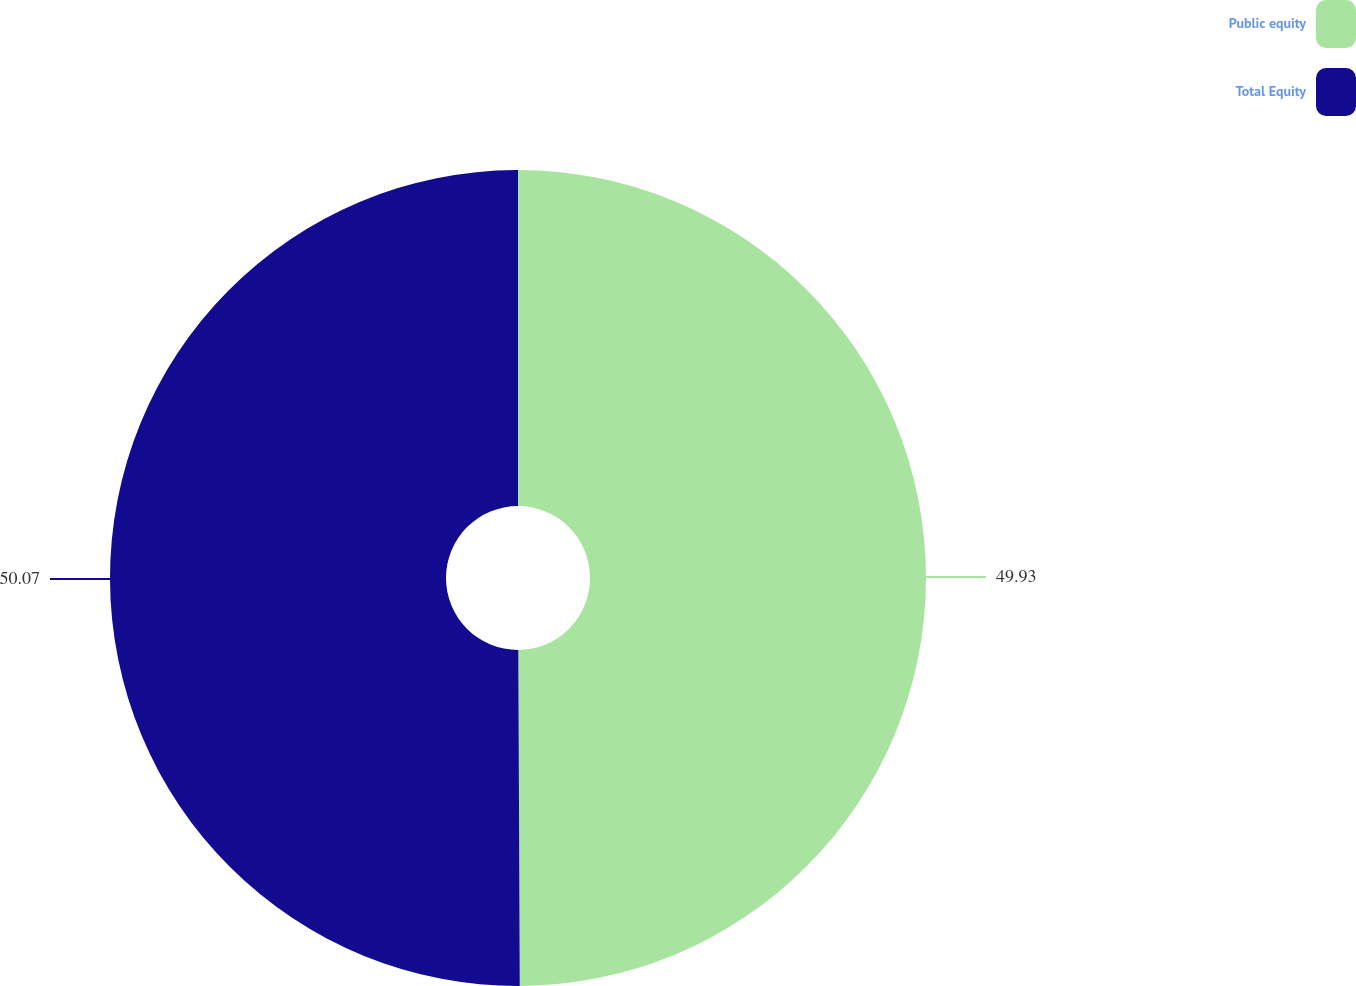Convert chart to OTSL. <chart><loc_0><loc_0><loc_500><loc_500><pie_chart><fcel>Public equity<fcel>Total Equity<nl><fcel>49.93%<fcel>50.07%<nl></chart> 